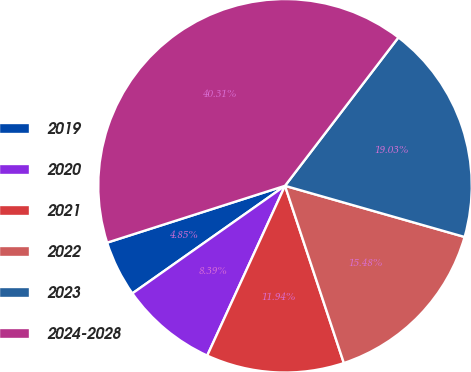Convert chart. <chart><loc_0><loc_0><loc_500><loc_500><pie_chart><fcel>2019<fcel>2020<fcel>2021<fcel>2022<fcel>2023<fcel>2024-2028<nl><fcel>4.85%<fcel>8.39%<fcel>11.94%<fcel>15.48%<fcel>19.03%<fcel>40.31%<nl></chart> 